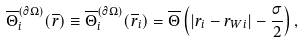<formula> <loc_0><loc_0><loc_500><loc_500>\overline { \Theta } _ { i } ^ { ( \partial \Omega ) } ( \overline { r } ) \equiv \overline { \Theta } _ { i } ^ { ( \partial \Omega ) } ( \overline { r } _ { i } ) = \overline { \Theta } \left ( \left | r _ { i } - r _ { W i } \right | - \frac { \sigma } { 2 } \right ) ,</formula> 